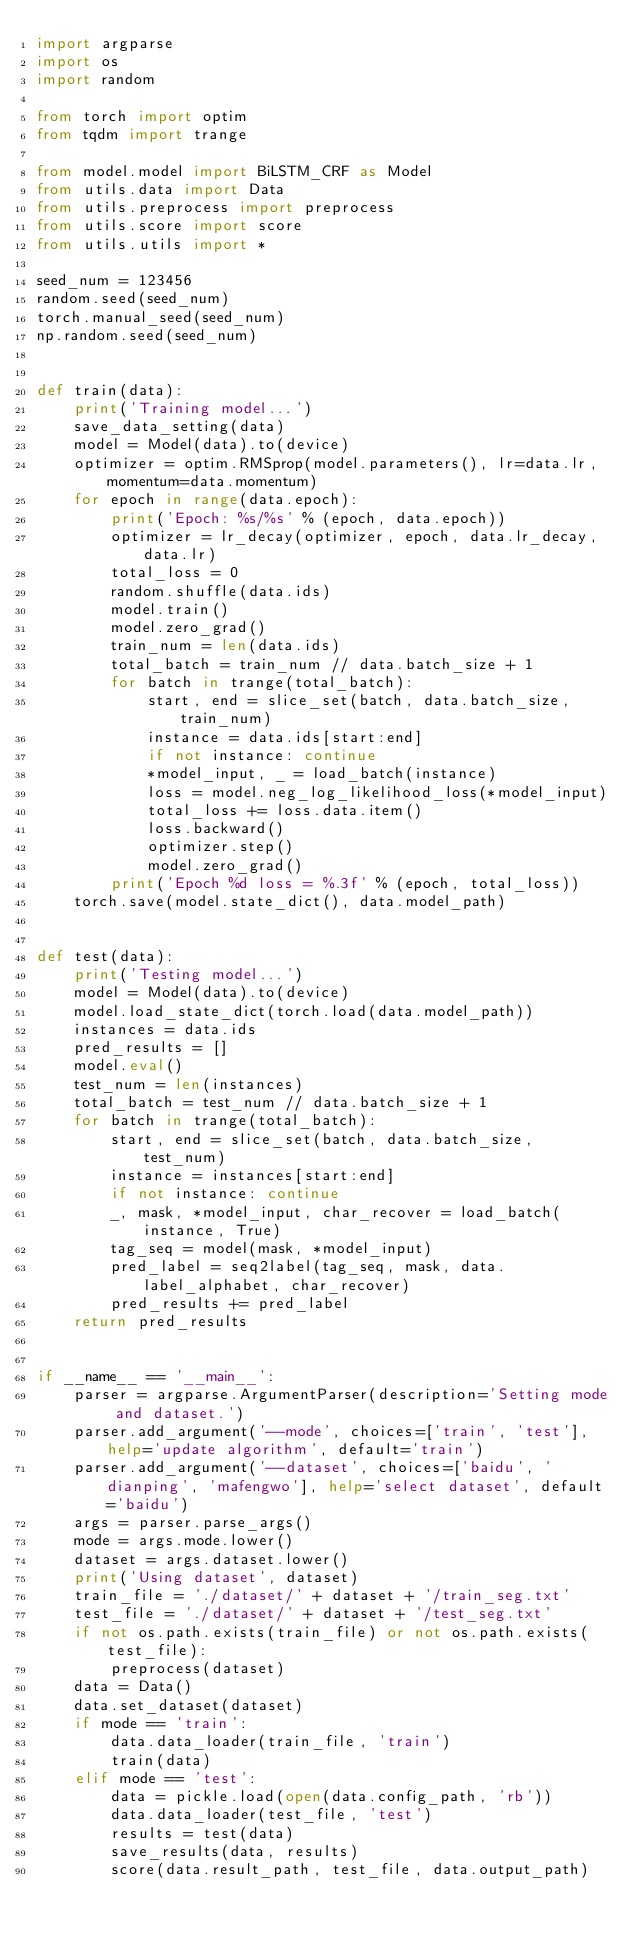Convert code to text. <code><loc_0><loc_0><loc_500><loc_500><_Python_>import argparse
import os
import random

from torch import optim
from tqdm import trange

from model.model import BiLSTM_CRF as Model
from utils.data import Data
from utils.preprocess import preprocess
from utils.score import score
from utils.utils import *

seed_num = 123456
random.seed(seed_num)
torch.manual_seed(seed_num)
np.random.seed(seed_num)


def train(data):
    print('Training model...')
    save_data_setting(data)
    model = Model(data).to(device)
    optimizer = optim.RMSprop(model.parameters(), lr=data.lr, momentum=data.momentum)
    for epoch in range(data.epoch):
        print('Epoch: %s/%s' % (epoch, data.epoch))
        optimizer = lr_decay(optimizer, epoch, data.lr_decay, data.lr)
        total_loss = 0
        random.shuffle(data.ids)
        model.train()
        model.zero_grad()
        train_num = len(data.ids)
        total_batch = train_num // data.batch_size + 1
        for batch in trange(total_batch):
            start, end = slice_set(batch, data.batch_size, train_num)
            instance = data.ids[start:end]
            if not instance: continue
            *model_input, _ = load_batch(instance)
            loss = model.neg_log_likelihood_loss(*model_input)
            total_loss += loss.data.item()
            loss.backward()
            optimizer.step()
            model.zero_grad()
        print('Epoch %d loss = %.3f' % (epoch, total_loss))
    torch.save(model.state_dict(), data.model_path)


def test(data):
    print('Testing model...')
    model = Model(data).to(device)
    model.load_state_dict(torch.load(data.model_path))
    instances = data.ids
    pred_results = []
    model.eval()
    test_num = len(instances)
    total_batch = test_num // data.batch_size + 1
    for batch in trange(total_batch):
        start, end = slice_set(batch, data.batch_size, test_num)
        instance = instances[start:end]
        if not instance: continue
        _, mask, *model_input, char_recover = load_batch(instance, True)
        tag_seq = model(mask, *model_input)
        pred_label = seq2label(tag_seq, mask, data.label_alphabet, char_recover)
        pred_results += pred_label
    return pred_results


if __name__ == '__main__':
    parser = argparse.ArgumentParser(description='Setting mode and dataset.')
    parser.add_argument('--mode', choices=['train', 'test'], help='update algorithm', default='train')
    parser.add_argument('--dataset', choices=['baidu', 'dianping', 'mafengwo'], help='select dataset', default='baidu')
    args = parser.parse_args()
    mode = args.mode.lower()
    dataset = args.dataset.lower()
    print('Using dataset', dataset)
    train_file = './dataset/' + dataset + '/train_seg.txt'
    test_file = './dataset/' + dataset + '/test_seg.txt'
    if not os.path.exists(train_file) or not os.path.exists(test_file):
        preprocess(dataset)
    data = Data()
    data.set_dataset(dataset)
    if mode == 'train':
        data.data_loader(train_file, 'train')
        train(data)
    elif mode == 'test':
        data = pickle.load(open(data.config_path, 'rb'))
        data.data_loader(test_file, 'test')
        results = test(data)
        save_results(data, results)
        score(data.result_path, test_file, data.output_path)
</code> 